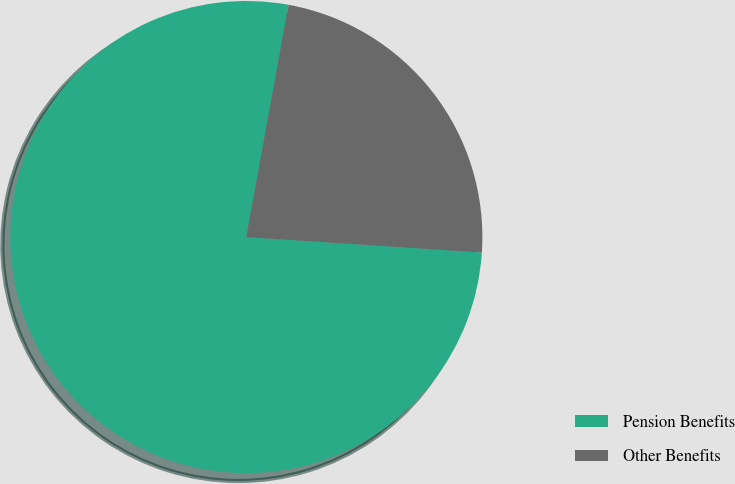<chart> <loc_0><loc_0><loc_500><loc_500><pie_chart><fcel>Pension Benefits<fcel>Other Benefits<nl><fcel>76.83%<fcel>23.17%<nl></chart> 